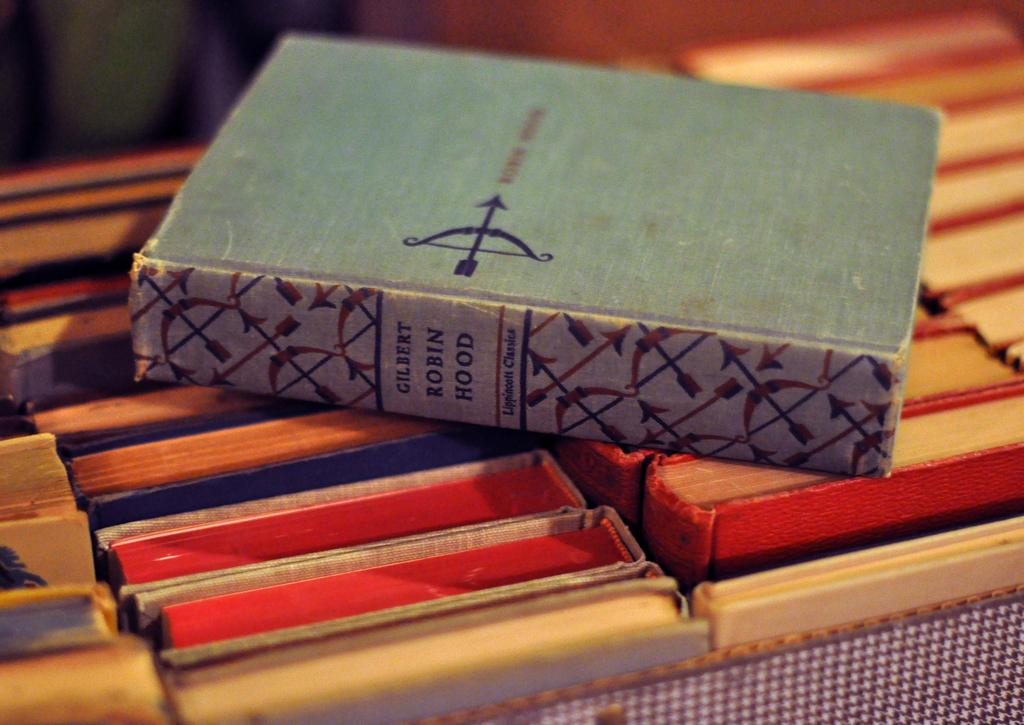<image>
Summarize the visual content of the image. The book Robin Hood by Gilbert on top of other books 